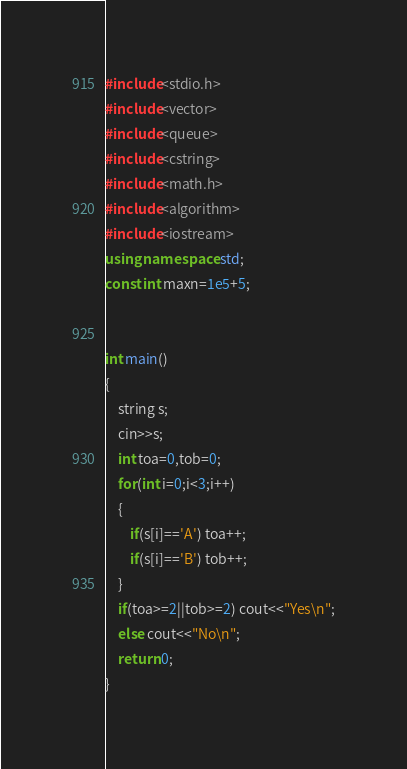<code> <loc_0><loc_0><loc_500><loc_500><_C++_>#include<stdio.h>
#include<vector>
#include<queue>
#include<cstring>
#include<math.h>
#include<algorithm>
#include<iostream>
using namespace std;
const int maxn=1e5+5;


int main()
{
	string s;
	cin>>s;
	int toa=0,tob=0;
	for(int i=0;i<3;i++)
	{
		if(s[i]=='A') toa++;
		if(s[i]=='B') tob++;
	}
	if(toa>=2||tob>=2) cout<<"Yes\n";
	else cout<<"No\n";
	return 0; 
}</code> 